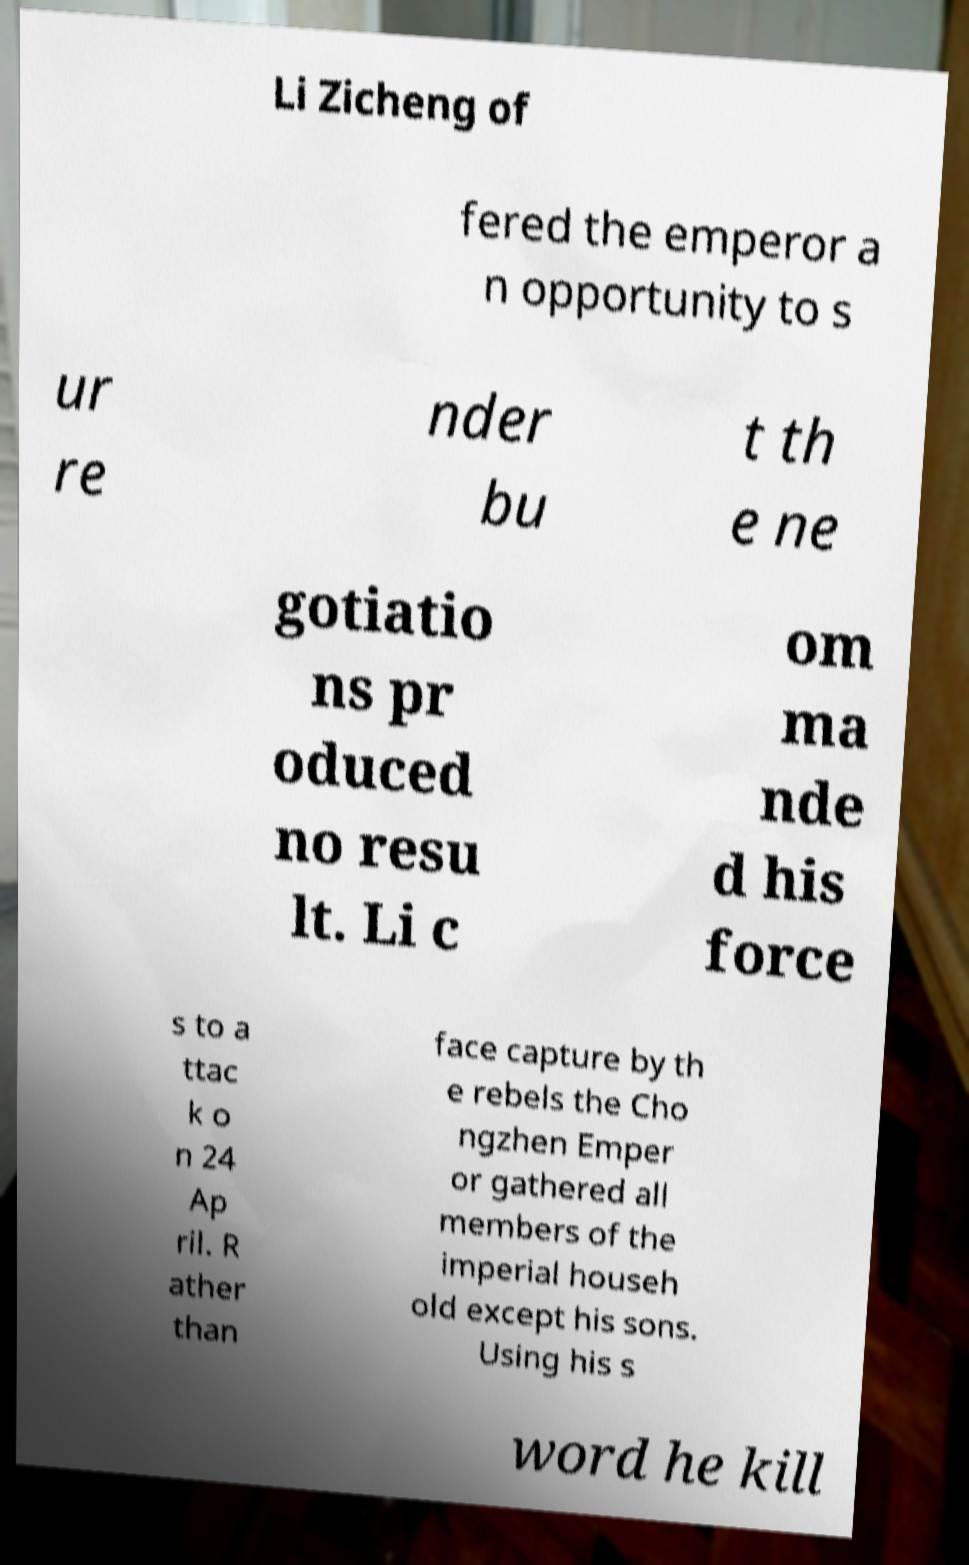Please read and relay the text visible in this image. What does it say? Li Zicheng of fered the emperor a n opportunity to s ur re nder bu t th e ne gotiatio ns pr oduced no resu lt. Li c om ma nde d his force s to a ttac k o n 24 Ap ril. R ather than face capture by th e rebels the Cho ngzhen Emper or gathered all members of the imperial househ old except his sons. Using his s word he kill 